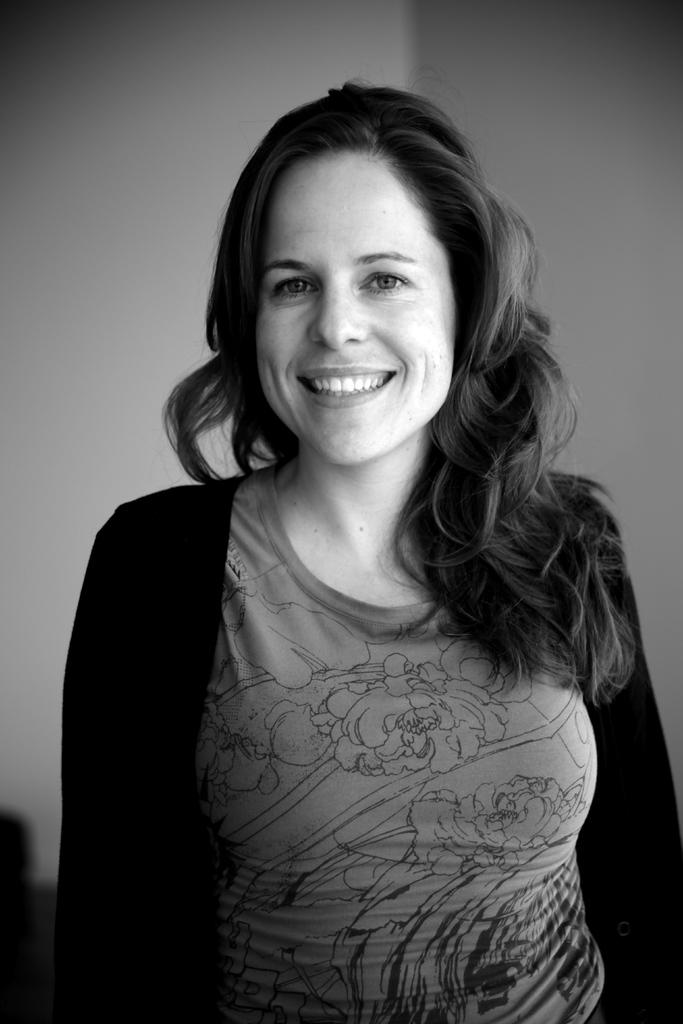Who is the main subject in the image? There is a woman in the image. What is the woman doing in the image? The woman is standing and smiling. What can be seen in the background of the image? There are walls visible in the background of the image. What type of account does the woman have in the image? There is no mention of an account in the image, as it features a woman standing and smiling with walls visible in the background. 